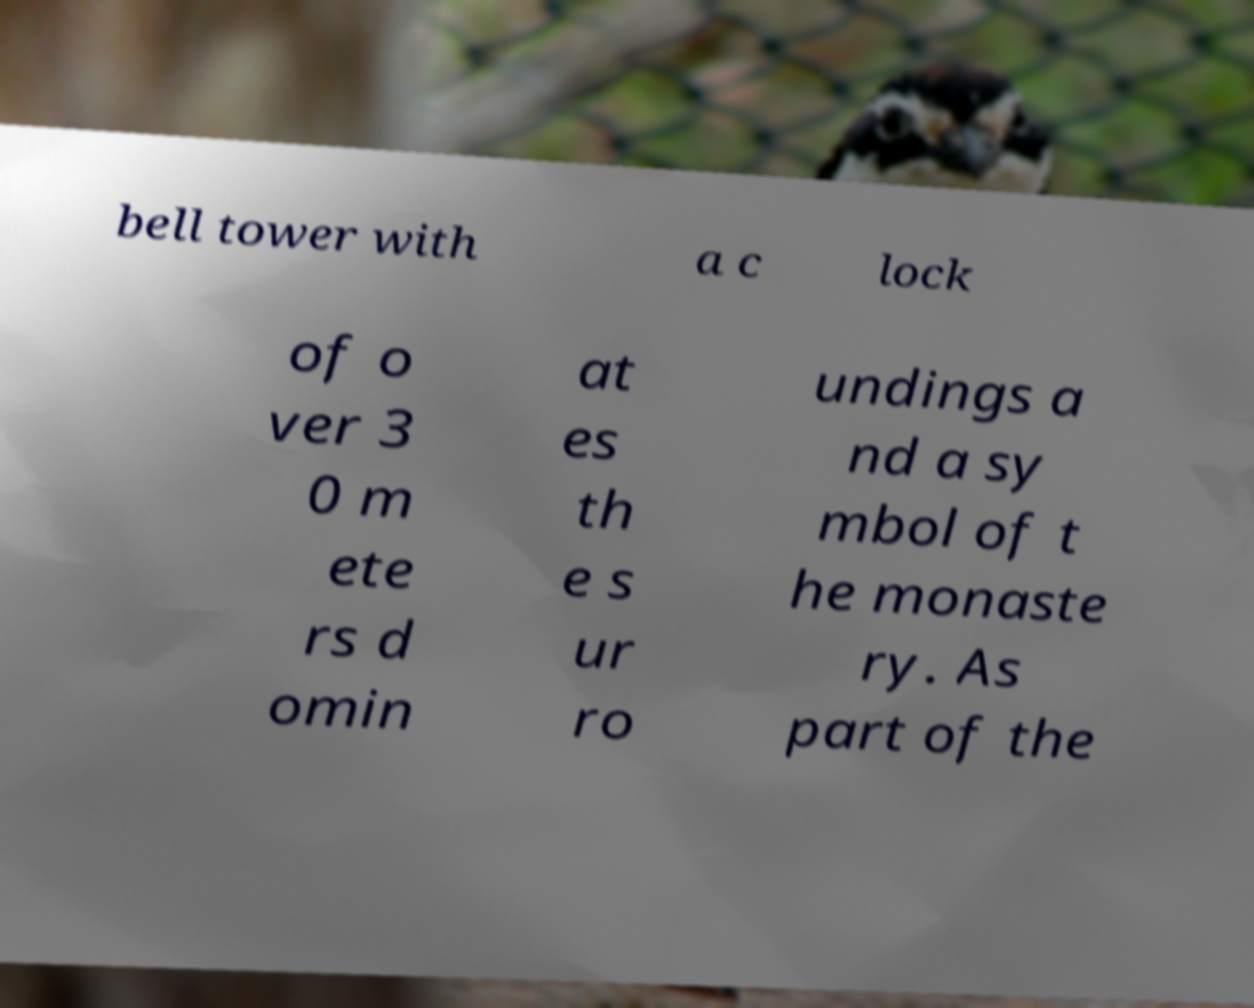Please read and relay the text visible in this image. What does it say? bell tower with a c lock of o ver 3 0 m ete rs d omin at es th e s ur ro undings a nd a sy mbol of t he monaste ry. As part of the 